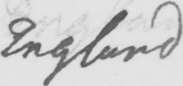Please provide the text content of this handwritten line. England 